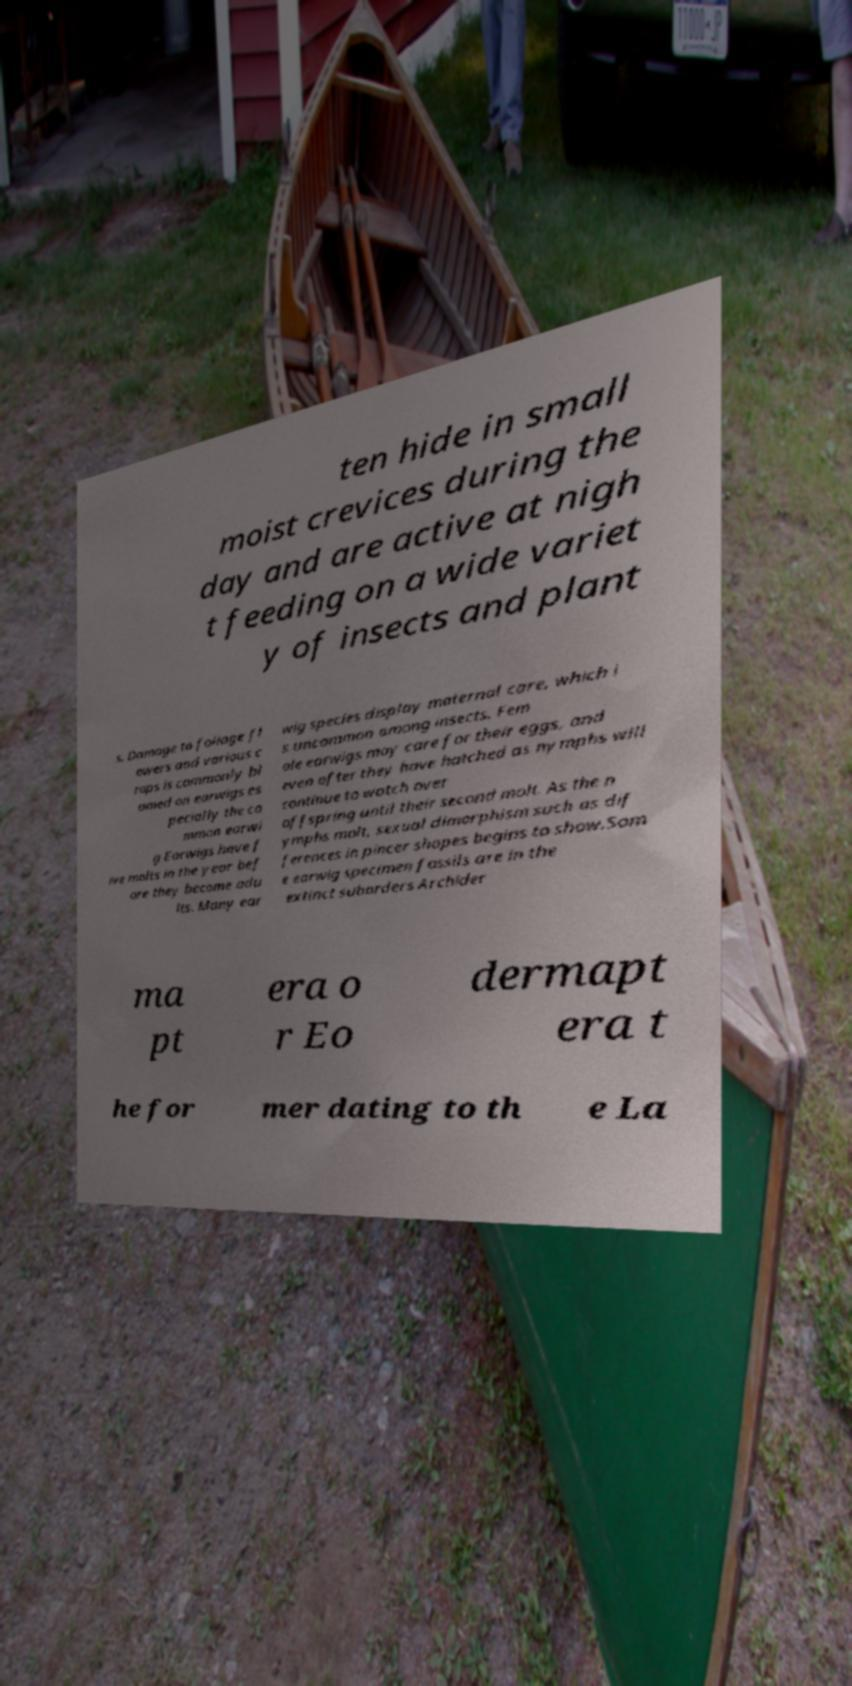For documentation purposes, I need the text within this image transcribed. Could you provide that? ten hide in small moist crevices during the day and are active at nigh t feeding on a wide variet y of insects and plant s. Damage to foliage fl owers and various c rops is commonly bl amed on earwigs es pecially the co mmon earwi g Earwigs have f ive molts in the year bef ore they become adu lts. Many ear wig species display maternal care, which i s uncommon among insects. Fem ale earwigs may care for their eggs, and even after they have hatched as nymphs will continue to watch over offspring until their second molt. As the n ymphs molt, sexual dimorphism such as dif ferences in pincer shapes begins to show.Som e earwig specimen fossils are in the extinct suborders Archider ma pt era o r Eo dermapt era t he for mer dating to th e La 